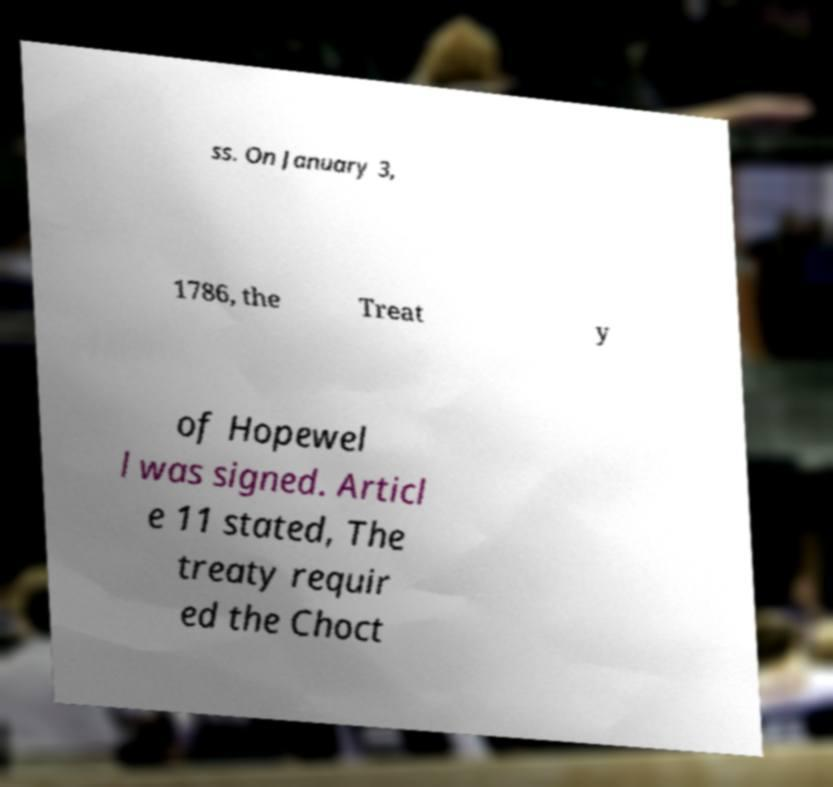Can you read and provide the text displayed in the image?This photo seems to have some interesting text. Can you extract and type it out for me? ss. On January 3, 1786, the Treat y of Hopewel l was signed. Articl e 11 stated, The treaty requir ed the Choct 